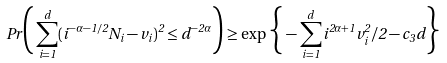Convert formula to latex. <formula><loc_0><loc_0><loc_500><loc_500>P r \Big { ( } \sum _ { i = 1 } ^ { d } ( i ^ { - \alpha - 1 / 2 } N _ { i } - v _ { i } ) ^ { 2 } \leq d ^ { - 2 \alpha } \Big { ) } \geq \exp \Big { \{ } - \sum _ { i = 1 } ^ { d } i ^ { 2 \alpha + 1 } v _ { i } ^ { 2 } / 2 - c _ { 3 } d \Big { \} }</formula> 